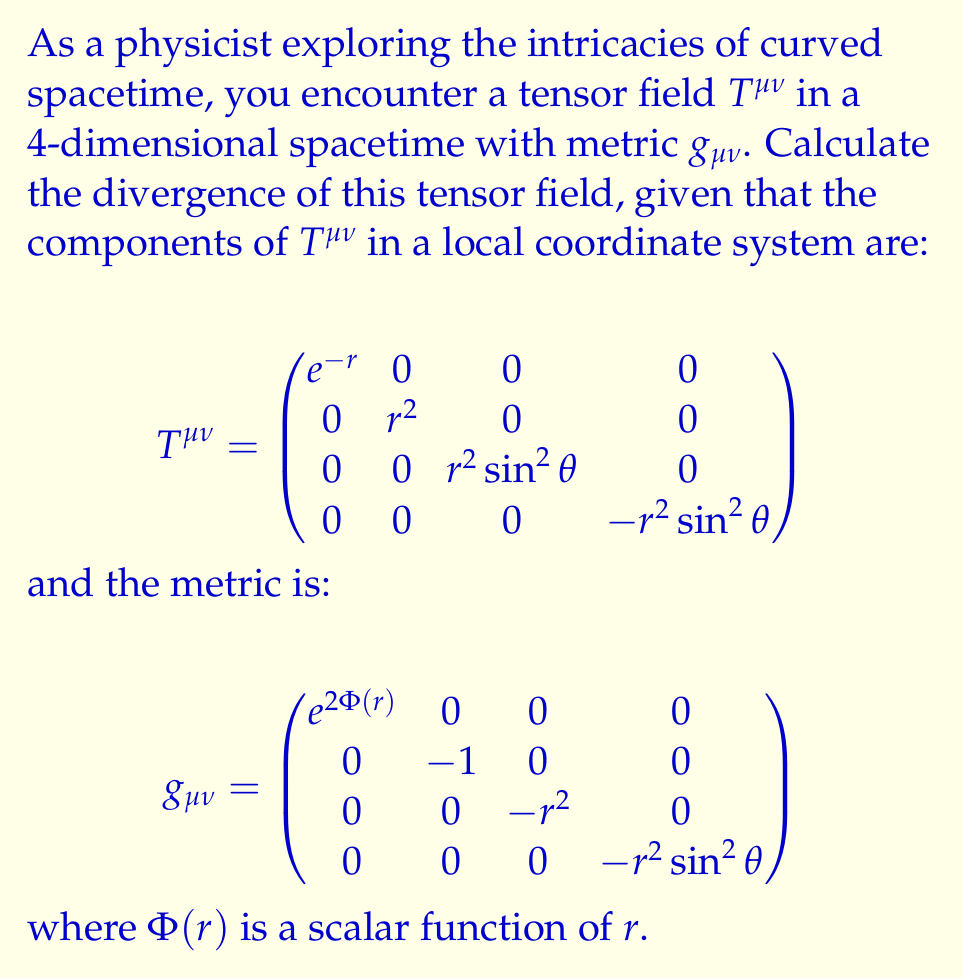Give your solution to this math problem. To compute the divergence of a tensor field in curved spacetime, we need to use the covariant derivative. The divergence of a rank-2 tensor $T^{\mu\nu}$ is given by:

$$\nabla_\mu T^{\mu\nu} = \partial_\mu T^{\mu\nu} + \Gamma^\mu_{\mu\lambda}T^{\lambda\nu} + \Gamma^\nu_{\mu\lambda}T^{\mu\lambda}$$

where $\Gamma^\mu_{\nu\lambda}$ are the Christoffel symbols.

Step 1: Calculate the partial derivatives $\partial_\mu T^{\mu\nu}$
Due to the diagonal nature of $T^{\mu\nu}$, we only need to consider:
$$\partial_0 T^{00} = -e^{-r}, \quad \partial_1 T^{11} = 2r, \quad \partial_2 T^{22} = 2r\sin^2\theta, \quad \partial_3 T^{33} = -2r\sin^2\theta$$

Step 2: Calculate the Christoffel symbols
For the given metric, the non-zero Christoffel symbols are:
$$\Gamma^0_{01} = \Phi'(r), \quad \Gamma^1_{00} = e^{2\Phi(r)}\Phi'(r), \quad \Gamma^1_{22} = r, \quad \Gamma^1_{33} = r\sin^2\theta$$
$$\Gamma^2_{12} = \frac{1}{r}, \quad \Gamma^2_{33} = -\sin\theta\cos\theta, \quad \Gamma^3_{13} = \frac{1}{r}, \quad \Gamma^3_{23} = \cot\theta$$

Step 3: Evaluate $\Gamma^\mu_{\mu\lambda}T^{\lambda\nu}$
$$\Gamma^\mu_{\mu0}T^{0\nu} = \Phi'(r)e^{-r}$$
$$\Gamma^\mu_{\mu1}T^{1\nu} = \frac{2}{r}r^2 = 2r$$
$$\Gamma^\mu_{\mu2}T^{2\nu} = \frac{1}{r}r^2\sin^2\theta = r\sin^2\theta$$
$$\Gamma^\mu_{\mu3}T^{3\nu} = \cot\theta(-r^2\sin^2\theta) = -r^2\sin\theta\cos\theta$$

Step 4: Evaluate $\Gamma^\nu_{\mu\lambda}T^{\mu\lambda}$
This term is zero for $\nu \neq \mu$ due to the diagonal nature of $T^{\mu\nu}$.

Step 5: Combine all terms
$$\nabla_\mu T^{\mu0} = -e^{-r} + \Phi'(r)e^{-r} = e^{-r}(\Phi'(r) - 1)$$
$$\nabla_\mu T^{\mu1} = 2r + 2r = 4r$$
$$\nabla_\mu T^{\mu2} = 2r\sin^2\theta + r\sin^2\theta = 3r\sin^2\theta$$
$$\nabla_\mu T^{\mu3} = -2r\sin^2\theta - r^2\sin\theta\cos\theta = -2r\sin^2\theta - r^2\sin\theta\cos\theta$$

Therefore, the divergence of the tensor field is:
$$\nabla_\mu T^{\mu\nu} = \begin{pmatrix}
e^{-r}(\Phi'(r) - 1) \\
4r \\
3r\sin^2\theta \\
-2r\sin^2\theta - r^2\sin\theta\cos\theta
\end{pmatrix}$$
Answer: $$\nabla_\mu T^{\mu\nu} = \begin{pmatrix}
e^{-r}(\Phi'(r) - 1) \\
4r \\
3r\sin^2\theta \\
-2r\sin^2\theta - r^2\sin\theta\cos\theta
\end{pmatrix}$$ 